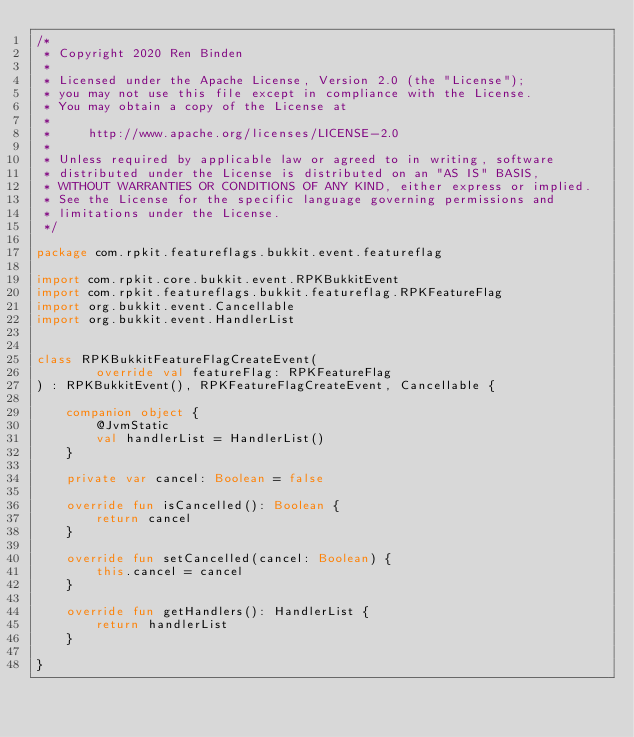<code> <loc_0><loc_0><loc_500><loc_500><_Kotlin_>/*
 * Copyright 2020 Ren Binden
 *
 * Licensed under the Apache License, Version 2.0 (the "License");
 * you may not use this file except in compliance with the License.
 * You may obtain a copy of the License at
 *
 *     http://www.apache.org/licenses/LICENSE-2.0
 *
 * Unless required by applicable law or agreed to in writing, software
 * distributed under the License is distributed on an "AS IS" BASIS,
 * WITHOUT WARRANTIES OR CONDITIONS OF ANY KIND, either express or implied.
 * See the License for the specific language governing permissions and
 * limitations under the License.
 */

package com.rpkit.featureflags.bukkit.event.featureflag

import com.rpkit.core.bukkit.event.RPKBukkitEvent
import com.rpkit.featureflags.bukkit.featureflag.RPKFeatureFlag
import org.bukkit.event.Cancellable
import org.bukkit.event.HandlerList


class RPKBukkitFeatureFlagCreateEvent(
        override val featureFlag: RPKFeatureFlag
) : RPKBukkitEvent(), RPKFeatureFlagCreateEvent, Cancellable {

    companion object {
        @JvmStatic
        val handlerList = HandlerList()
    }

    private var cancel: Boolean = false

    override fun isCancelled(): Boolean {
        return cancel
    }

    override fun setCancelled(cancel: Boolean) {
        this.cancel = cancel
    }

    override fun getHandlers(): HandlerList {
        return handlerList
    }

}</code> 